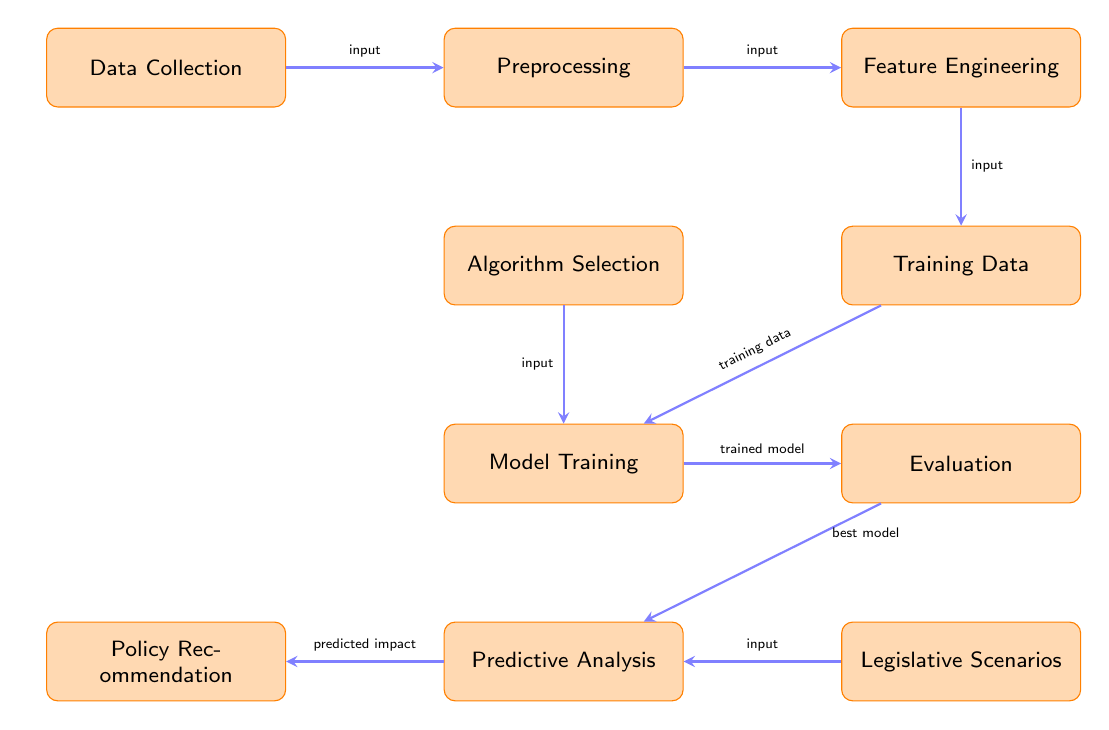What is the first step in the process? The diagram shows that "Data Collection" is the first node, indicating that data collection is the initial step.
Answer: Data Collection How many nodes are there in total? By counting each rectangular node in the diagram, there are ten distinct nodes represented.
Answer: Ten What connects Model Training and Evaluation? The arrow labeled "trained model" connects the "Model Training" node to the "Evaluation" node, indicating the flow of the process.
Answer: Trained model Which process follows Algorithm Selection? Looking at the arrangement in the diagram, "Model Training" directly follows "Algorithm Selection" based on the sequence of the nodes.
Answer: Model Training What is the relationship between Predictive Analysis and Policy Recommendation? The flow indicates that the "Predictive Analysis" node sends its output to the "Policy Recommendation" node, indicating that the analysis informs policy recommendations.
Answer: Predictive Analysis informs Policy Recommendation What is the last step in the process? The final node in the diagram is "Policy Recommendation," which represents the last step in the predictive analysis process.
Answer: Policy Recommendation What type of analysis is performed after Evaluation? The arrow leading from "Evaluation" to "Legislative Scenarios" signifies that the type of analysis performed after evaluation is related to legislative scenarios.
Answer: Legislative Scenarios In what order should "Preprocessing" and "Feature Engineering" be performed? The diagram shows an arrow from "Preprocessing" to "Feature Engineering," indicating that preprocessing must occur before feature engineering.
Answer: Preprocessing before Feature Engineering What is the input source for the training data? The diagram indicates that the "Training Data" node receives input from both the "Feature Engineering" node and "Algorithm Selection."
Answer: Feature Engineering and Algorithm Selection 